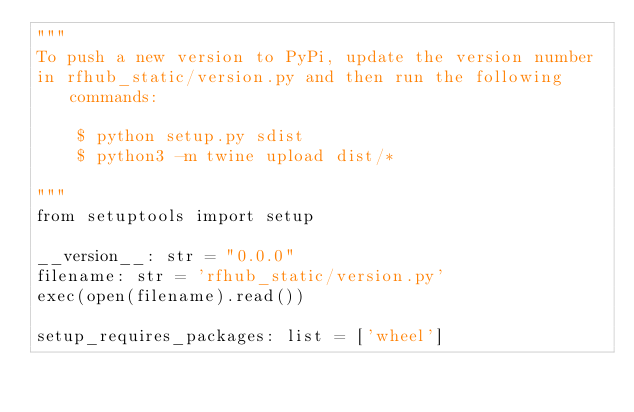<code> <loc_0><loc_0><loc_500><loc_500><_Python_>"""
To push a new version to PyPi, update the version number
in rfhub_static/version.py and then run the following commands:

    $ python setup.py sdist
    $ python3 -m twine upload dist/*

"""
from setuptools import setup

__version__: str = "0.0.0"
filename: str = 'rfhub_static/version.py'
exec(open(filename).read())

setup_requires_packages: list = ['wheel']</code> 